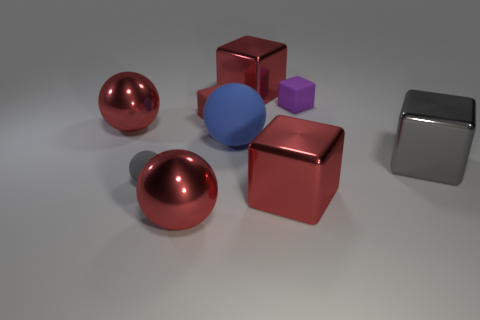How many things are red metal balls or large red objects in front of the blue rubber object?
Offer a terse response. 3. What shape is the gray rubber thing that is the same size as the purple rubber block?
Make the answer very short. Sphere. How many shiny cubes have the same color as the small sphere?
Offer a very short reply. 1. Are the red ball that is behind the gray matte object and the large blue object made of the same material?
Keep it short and to the point. No. The big blue thing has what shape?
Provide a short and direct response. Sphere. How many brown objects are large objects or balls?
Make the answer very short. 0. What number of other objects are the same material as the small red object?
Provide a succinct answer. 3. There is a matte thing in front of the large rubber thing; is it the same shape as the gray metallic object?
Your answer should be very brief. No. Are any cyan metallic cylinders visible?
Keep it short and to the point. No. Are there any other things that have the same shape as the red rubber thing?
Provide a succinct answer. Yes. 